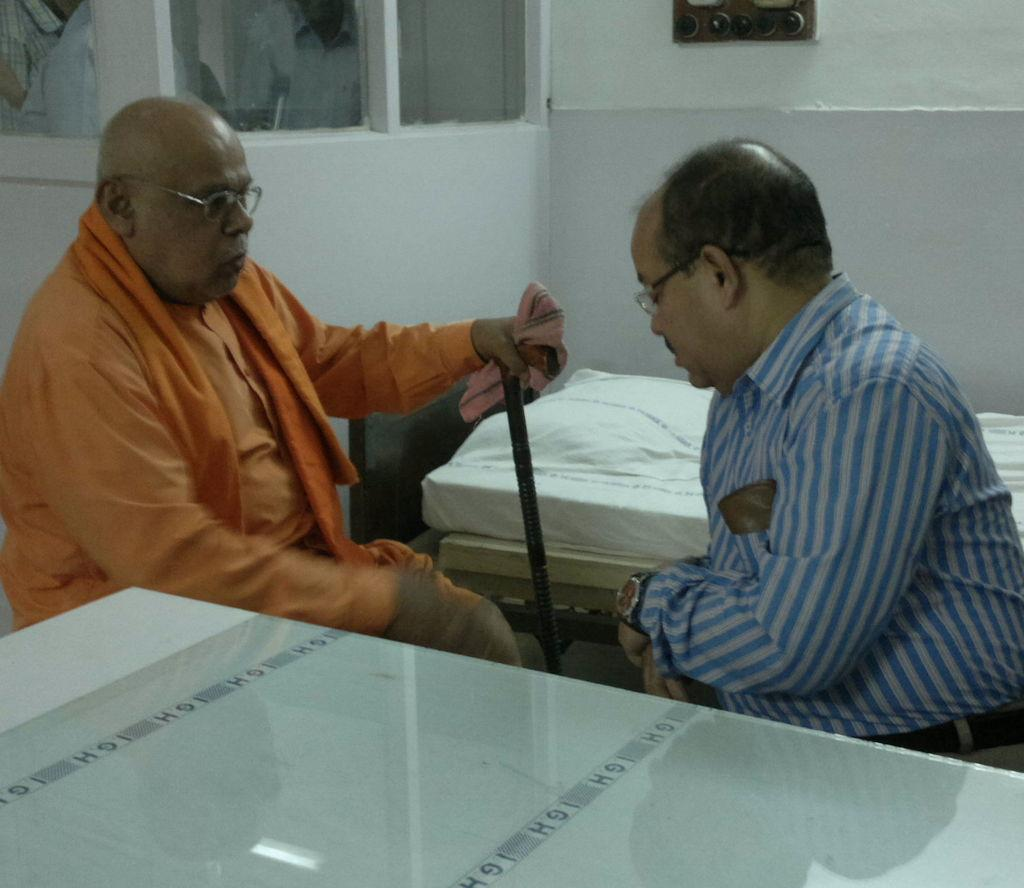How many people are in the image? There are two people in the image. What is one person doing in the image? One person is sitting. What is the other person doing in the image? The other person is catching a stick. What type of furniture is present in the image? There is a bed and a table in the image. What type of joke is being told by the person sitting in the image? There is no indication in the image that a joke is being told, so it cannot be determined from the picture. 